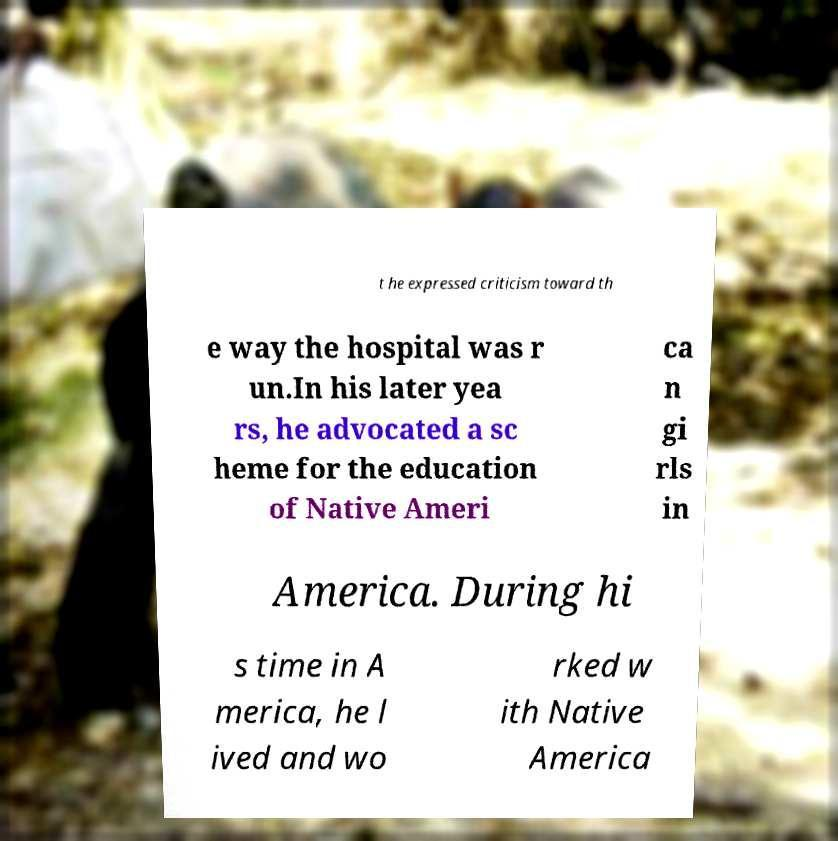Can you read and provide the text displayed in the image?This photo seems to have some interesting text. Can you extract and type it out for me? t he expressed criticism toward th e way the hospital was r un.In his later yea rs, he advocated a sc heme for the education of Native Ameri ca n gi rls in America. During hi s time in A merica, he l ived and wo rked w ith Native America 